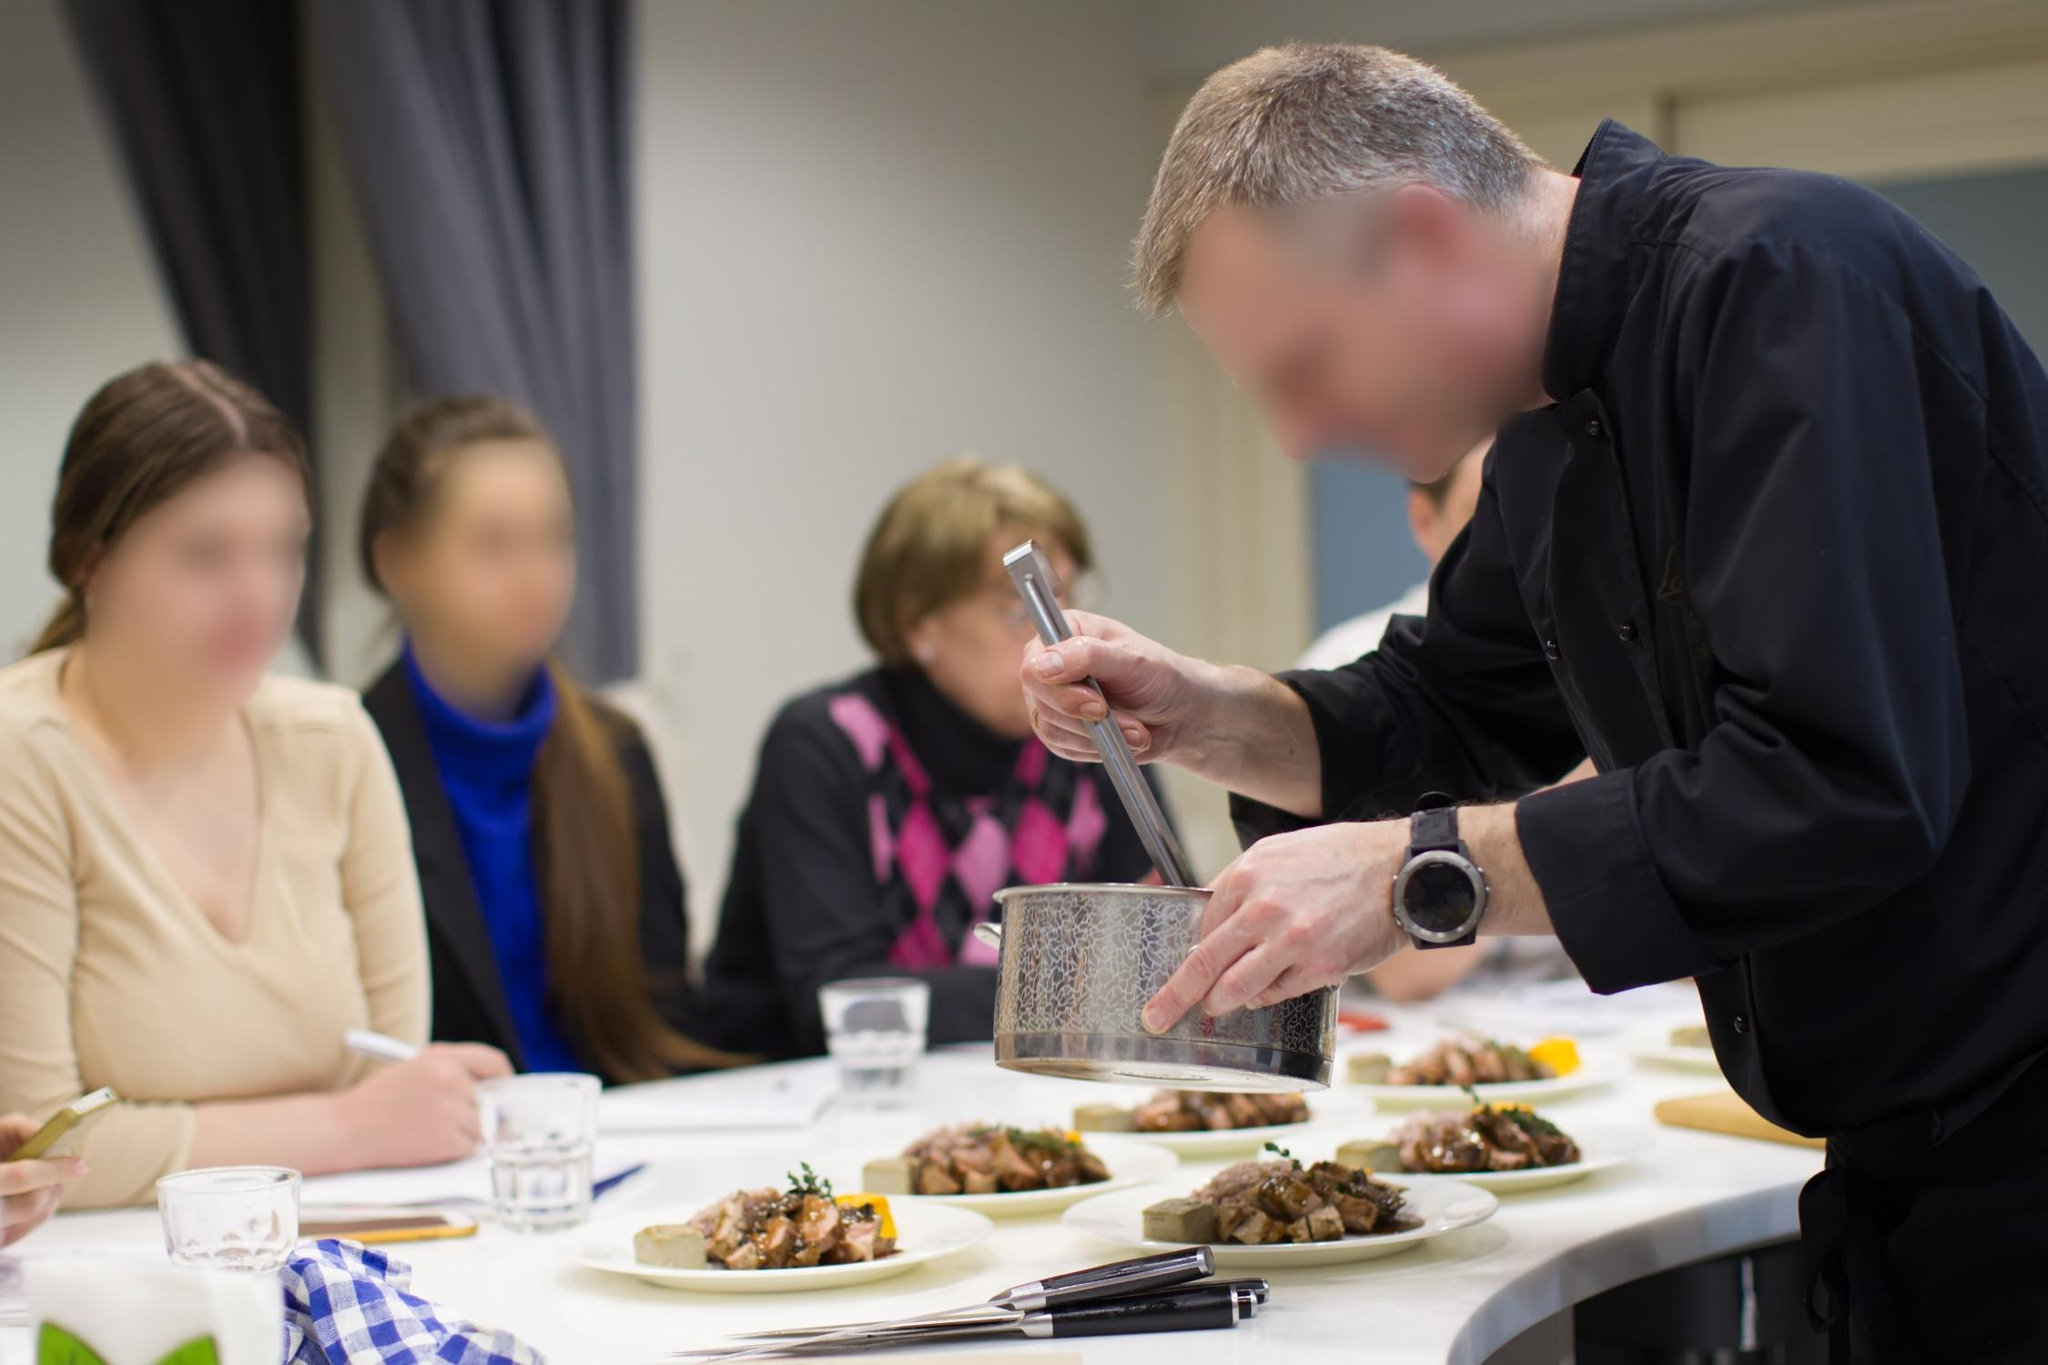What might the chef be thinking as he demonstrates his skills? As the chef demonstrates his skills, he might be thinking about ensuring that each step of his process is clearly communicated and visually accessible to the spectators. He would be considering how to best showcase techniques in a way that both educates and inspires. Additionally, he might be mentally planning the next stages of his demonstration, ensuring that each element of his presentation flows seamlessly. His focus would also be on creating a dish that not only looks and tastes great but also serves as a perfect example of culinary excellence for his eager audience. 